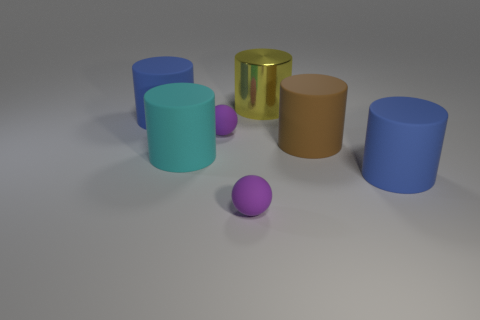Are there any patterns or similarities between these objects? Indeed, there are some patterns to note. All objects are geometrically symmetrical—either cylinders or spheres. They seem to be arranged with no particular order in terms of color coordination or size progression. However, they all share matte finishes except for the gold cylinder, which has a glossy surface. 